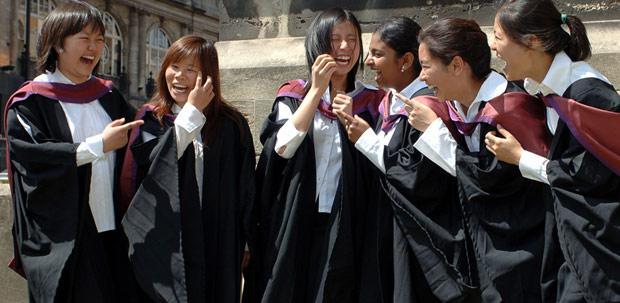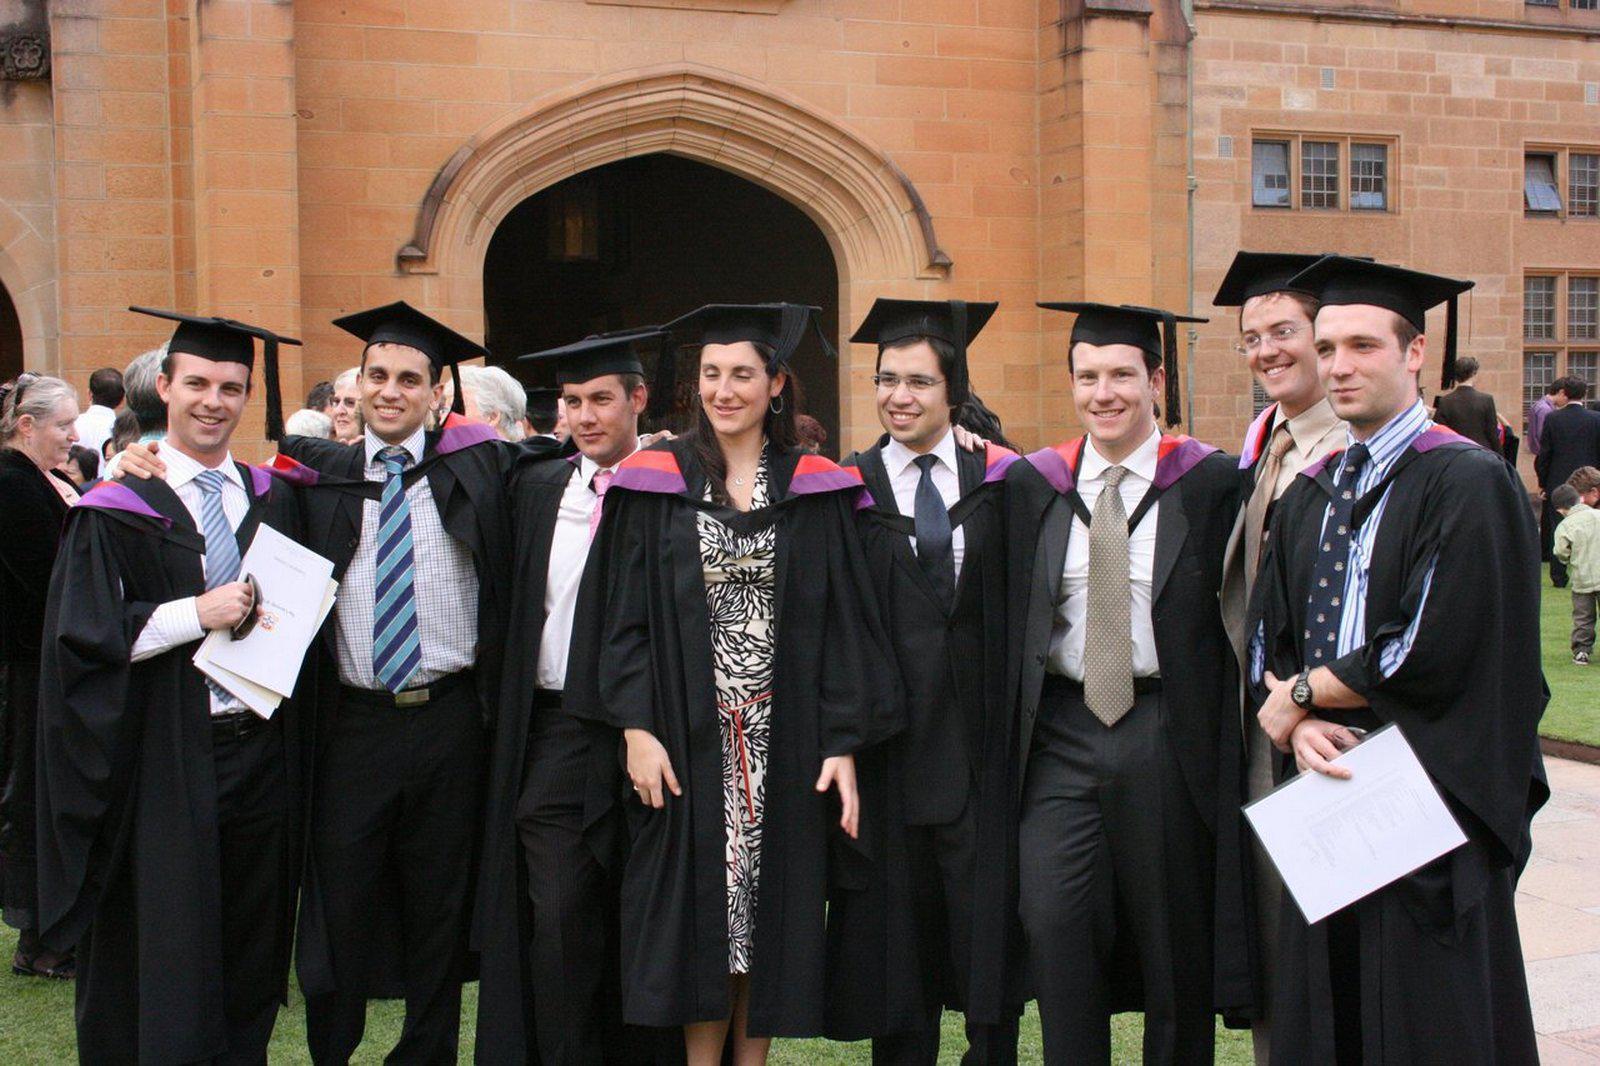The first image is the image on the left, the second image is the image on the right. Examine the images to the left and right. Is the description "The left image shows a group of four people." accurate? Answer yes or no. No. 